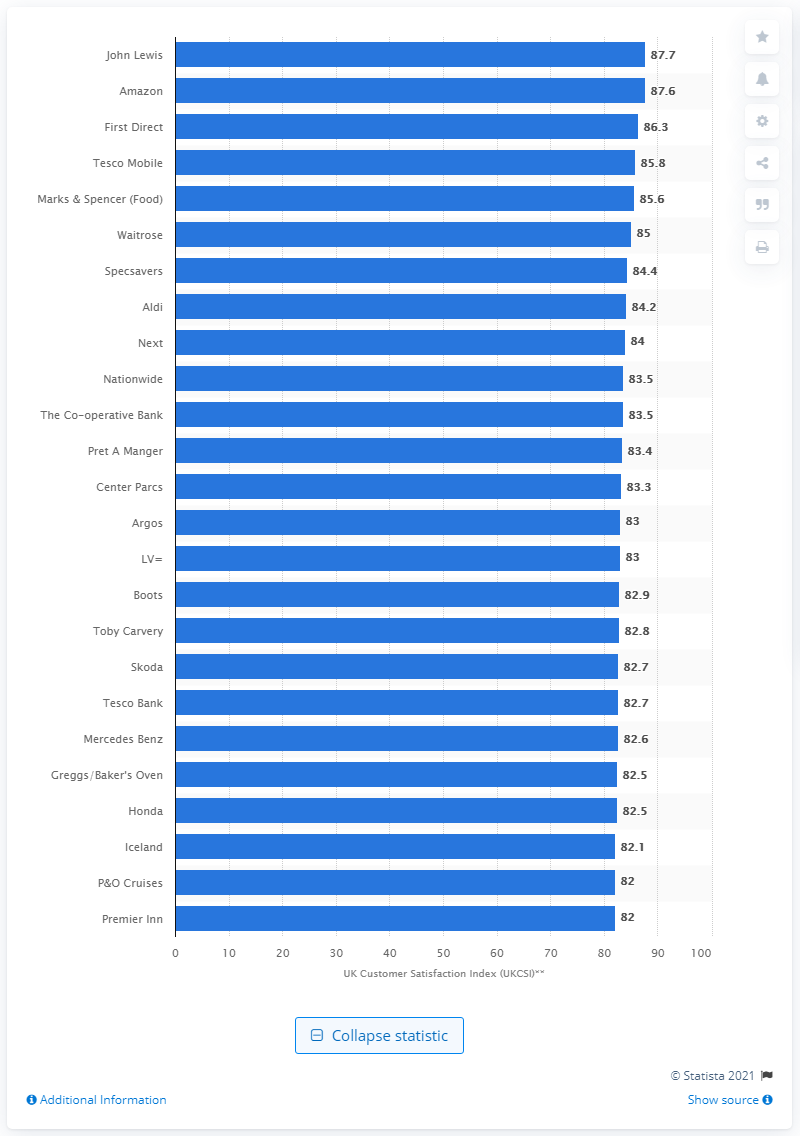List a handful of essential elements in this visual. Amazon's customer satisfaction index level was 87.6%. In July 2014, Amazon had the second highest customer satisfaction index in the UK. 